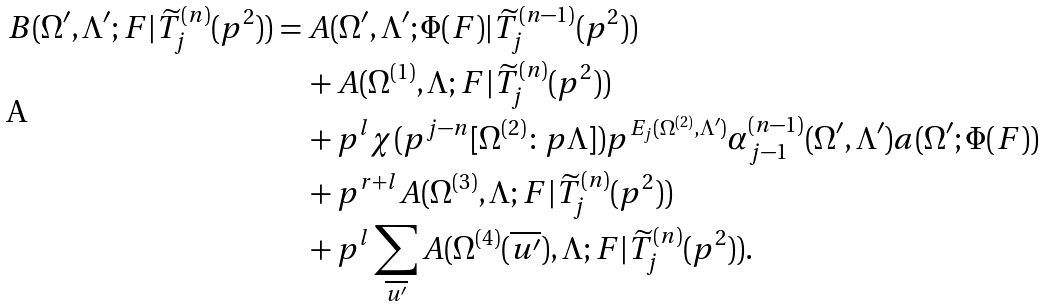<formula> <loc_0><loc_0><loc_500><loc_500>B ( \Omega ^ { \prime } , \Lambda ^ { \prime } ; F | \widetilde { T } ^ { ( n ) } _ { j } ( p ^ { 2 } ) ) & = A ( \Omega ^ { \prime } , \Lambda ^ { \prime } ; \Phi ( F ) | \widetilde { T } ^ { ( n - 1 ) } _ { j } ( p ^ { 2 } ) ) \\ & \quad + A ( \Omega ^ { ( 1 ) } , \Lambda ; F | \widetilde { T } ^ { ( n ) } _ { j } ( p ^ { 2 } ) ) \\ & \quad + p ^ { l } \chi ( p ^ { j - n } [ \Omega ^ { ( 2 ) } \colon p \Lambda ] ) p ^ { E _ { j } ( \Omega ^ { ( 2 ) } , \Lambda ^ { \prime } ) } \alpha ^ { ( n - 1 ) } _ { j - 1 } ( \Omega ^ { \prime } , \Lambda ^ { \prime } ) a ( \Omega ^ { \prime } ; \Phi ( F ) ) \\ & \quad + p ^ { r + l } A ( \Omega ^ { ( 3 ) } , \Lambda ; F | \widetilde { T } ^ { ( n ) } _ { j } ( p ^ { 2 } ) ) \\ & \quad + p ^ { l } \sum _ { \overline { u ^ { \prime } } } A ( \Omega ^ { ( 4 ) } ( \overline { u ^ { \prime } } ) , \Lambda ; F | \widetilde { T } ^ { ( n ) } _ { j } ( p ^ { 2 } ) ) .</formula> 